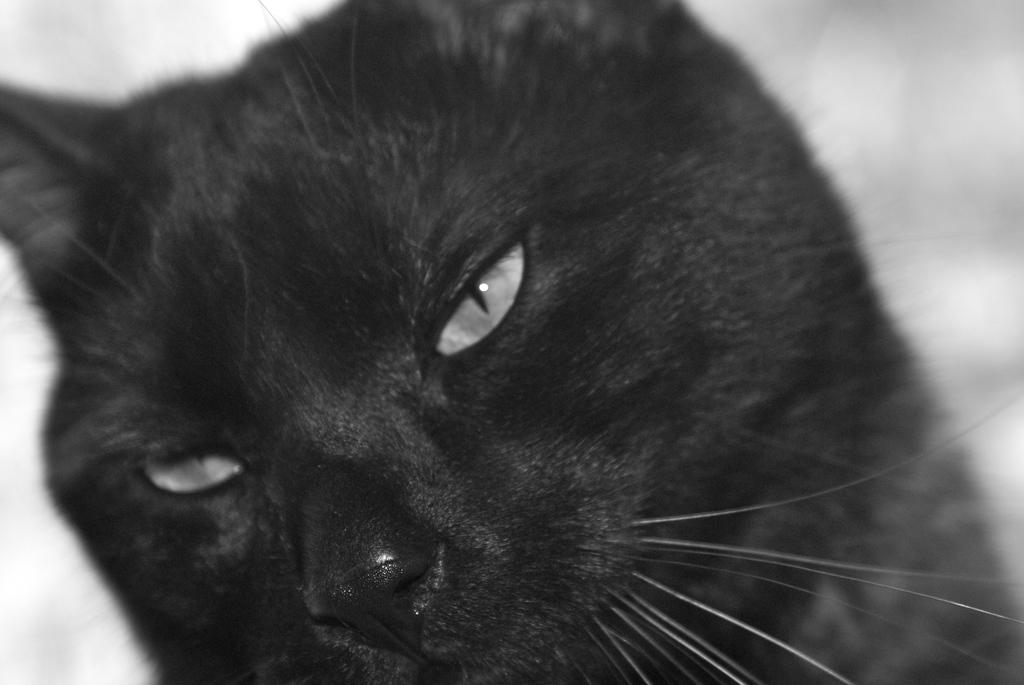What type of animal is in the image? There is a black color cat in the image. Can you describe the cat's appearance? The cat is black in color. How many books does the cat have in the image? There are no books present in the image; it features a black color cat. What decision does the cat make in the image? There is no indication of the cat making a decision in the image. 